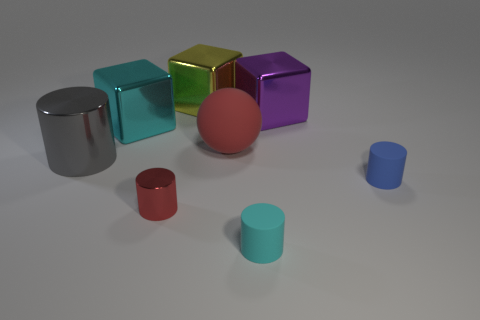Add 2 big green matte cubes. How many objects exist? 10 Subtract all balls. How many objects are left? 7 Subtract 0 green blocks. How many objects are left? 8 Subtract all gray shiny cubes. Subtract all large purple objects. How many objects are left? 7 Add 1 gray things. How many gray things are left? 2 Add 7 blue things. How many blue things exist? 8 